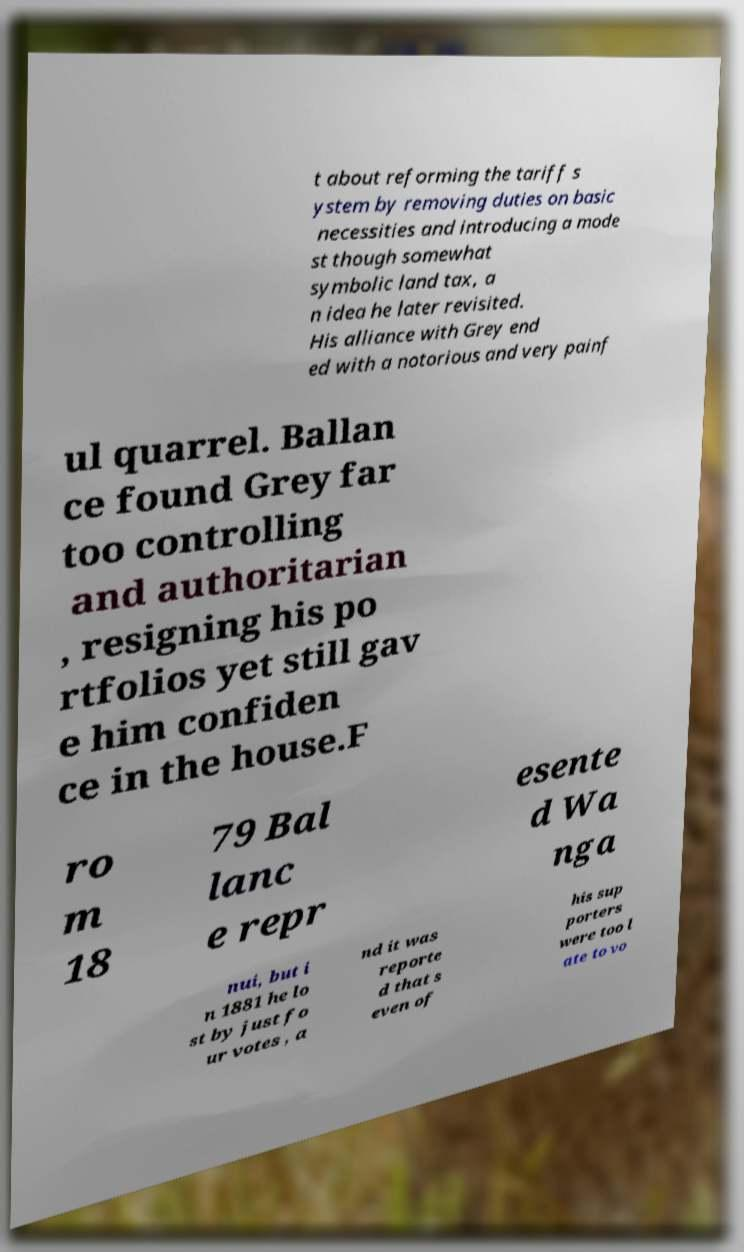Could you extract and type out the text from this image? t about reforming the tariff s ystem by removing duties on basic necessities and introducing a mode st though somewhat symbolic land tax, a n idea he later revisited. His alliance with Grey end ed with a notorious and very painf ul quarrel. Ballan ce found Grey far too controlling and authoritarian , resigning his po rtfolios yet still gav e him confiden ce in the house.F ro m 18 79 Bal lanc e repr esente d Wa nga nui, but i n 1881 he lo st by just fo ur votes , a nd it was reporte d that s even of his sup porters were too l ate to vo 